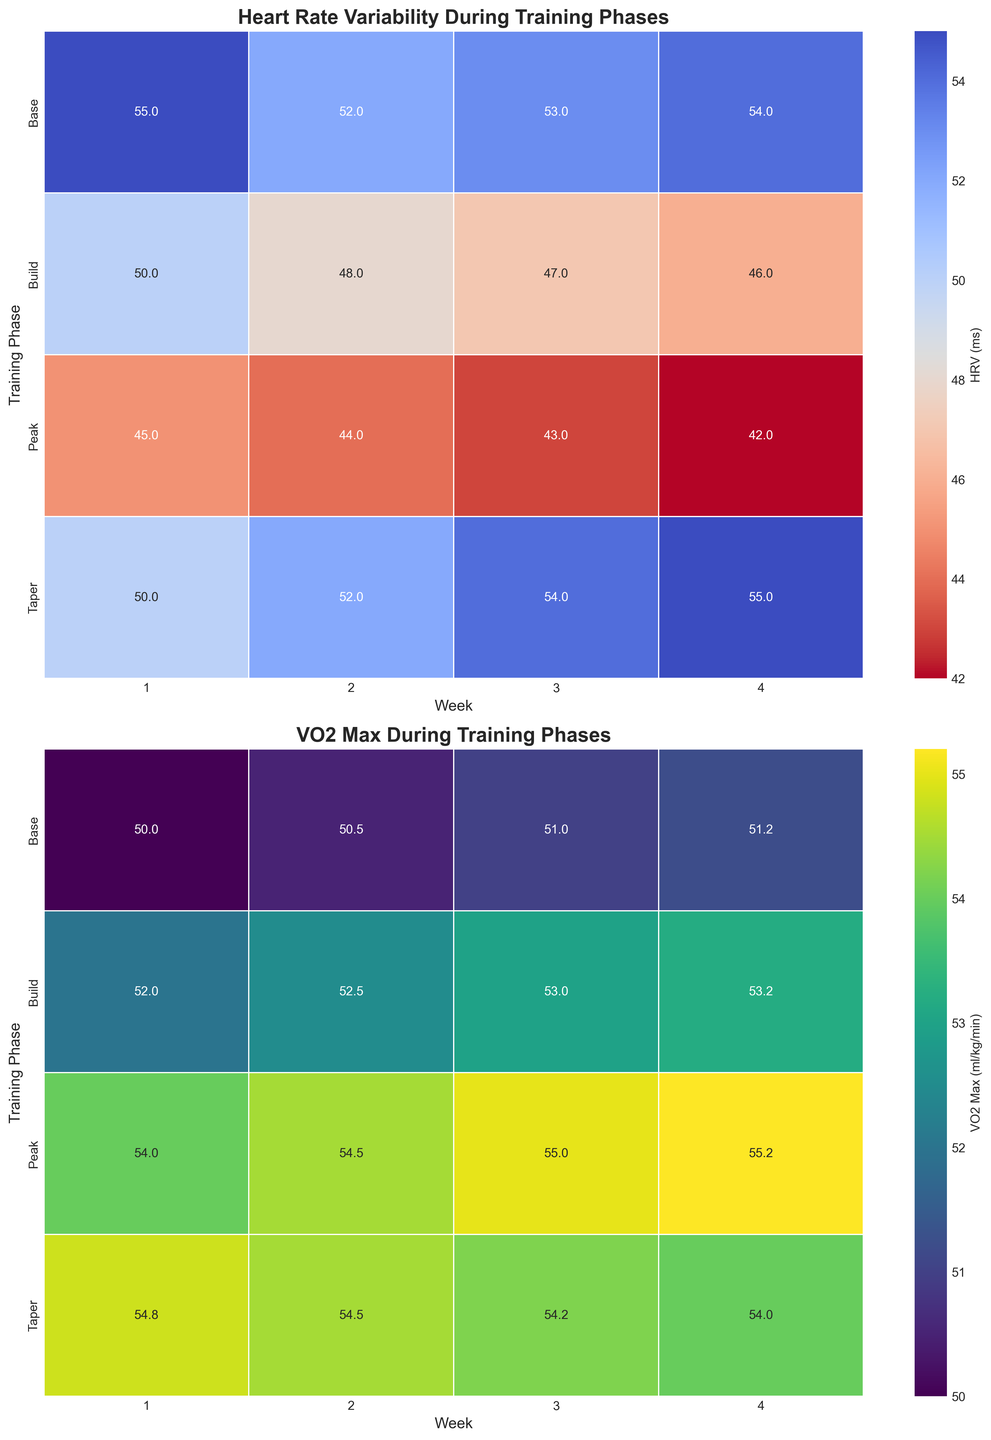What's the title of the first heatmap? The title of the first heatmap is usually found at the top of the visualization. According to the code provided, the title of the first heatmap is "Heart Rate Variability During Training Phases".
Answer: Heart Rate Variability During Training Phases What's the range of VO2 Max values in the second heatmap? The range is found by identifying the smallest and largest values in the VO2 Max heatmap. The minimum value is 50.0, and the maximum value is 55.2.
Answer: 50.0 to 55.2 Which training phase has the highest Heart Rate Variability (HRV) and during which week? Look at the first heatmap (Heart Rate Variability) and identify the highest value. The highest HRV value is 55 ms, which occurs in the Taper phase during Week 1.
Answer: Taper, Week 1 How does the Heart Rate Variability change from Week 1 to Week 4 in the Build phase? Track the values of HRV in the Build phase row from Week 1 to Week 4 in the heatmap. The values are 50, 48, 47, and 46 ms, showing a decreasing trend.
Answer: Decreases What is the average VO2 Max during the Peak phase? Sum the VO2 Max values for all weeks in the Peak phase, then divide by the number of weeks. The values are 54, 54.5, 55, and 55.2 ml/kg/min. The total is 218.7 and the average is 218.7 / 4 = 54.675.
Answer: 54.675 Which week has the smallest change in Heart Rate Variability across all training phases? Calculate the change in HRV from week to week for each phase and compare. The smallest change in HRV is from Week 3 to Week 4 in the Taper phase (54 ms to 55 ms, a change of 1 ms).
Answer: Week 3 to Week 4 in Taper How does the VO2 Max differ between the Base and Build phases during Week 1? Compare the VO2 Max values between the Base and Build rows for Week 1. The values are 50 and 52 respectively, so the difference is 52 - 50 = 2 ml/kg/min.
Answer: 2 ml/kg/min In which phase and week is the Heart Rate Variability at its lowest? Identify the lowest HRV value in the heatmap, which is in the Peak phase during Week 4 at 42 ms.
Answer: Peak, Week 4 What pattern do you observe in the VO2 Max values during the Taper phase? Examine the values in the Taper phase row: 54.8, 54.5, 54.2, and 54. They show a generally decreasing trend.
Answer: Decreasing trend How does the median Heart Rate Variability (HRV) in the Base phase compare to the median HRV in the Peak phase? List HRV values for the Base phase (55, 52, 53, 54) and for the Peak phase (45, 44, 43, 42). Calculate the medians: Base phase median is (52 + 53)/2 = 52.5, and Peak phase median is (43 + 44)/2 = 43.5. The median HRV in the Base phase is greater than in the Peak phase.
Answer: Greater in Base phase 